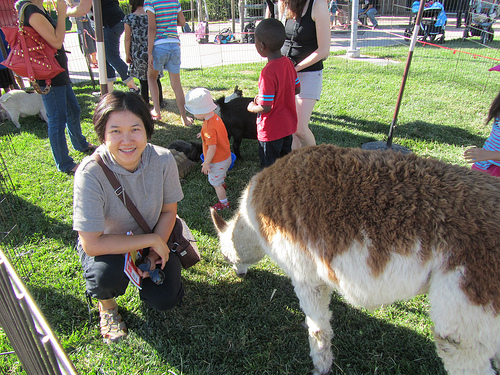Please provide a short description for this region: [0.36, 0.3, 0.47, 0.55]. The region showcases a young boy playing with animals, capturing an endearing and lively scene. 